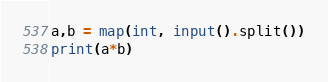<code> <loc_0><loc_0><loc_500><loc_500><_Python_>a,b = map(int, input().split())
print(a*b)</code> 